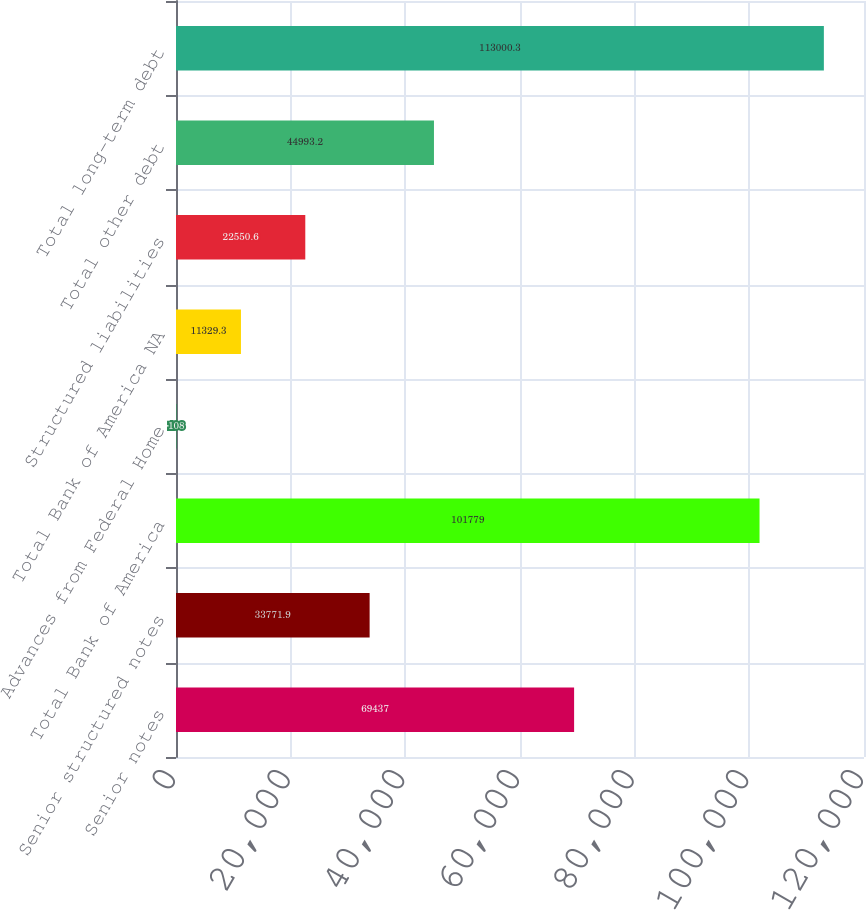Convert chart. <chart><loc_0><loc_0><loc_500><loc_500><bar_chart><fcel>Senior notes<fcel>Senior structured notes<fcel>Total Bank of America<fcel>Advances from Federal Home<fcel>Total Bank of America NA<fcel>Structured liabilities<fcel>Total other debt<fcel>Total long-term debt<nl><fcel>69437<fcel>33771.9<fcel>101779<fcel>108<fcel>11329.3<fcel>22550.6<fcel>44993.2<fcel>113000<nl></chart> 